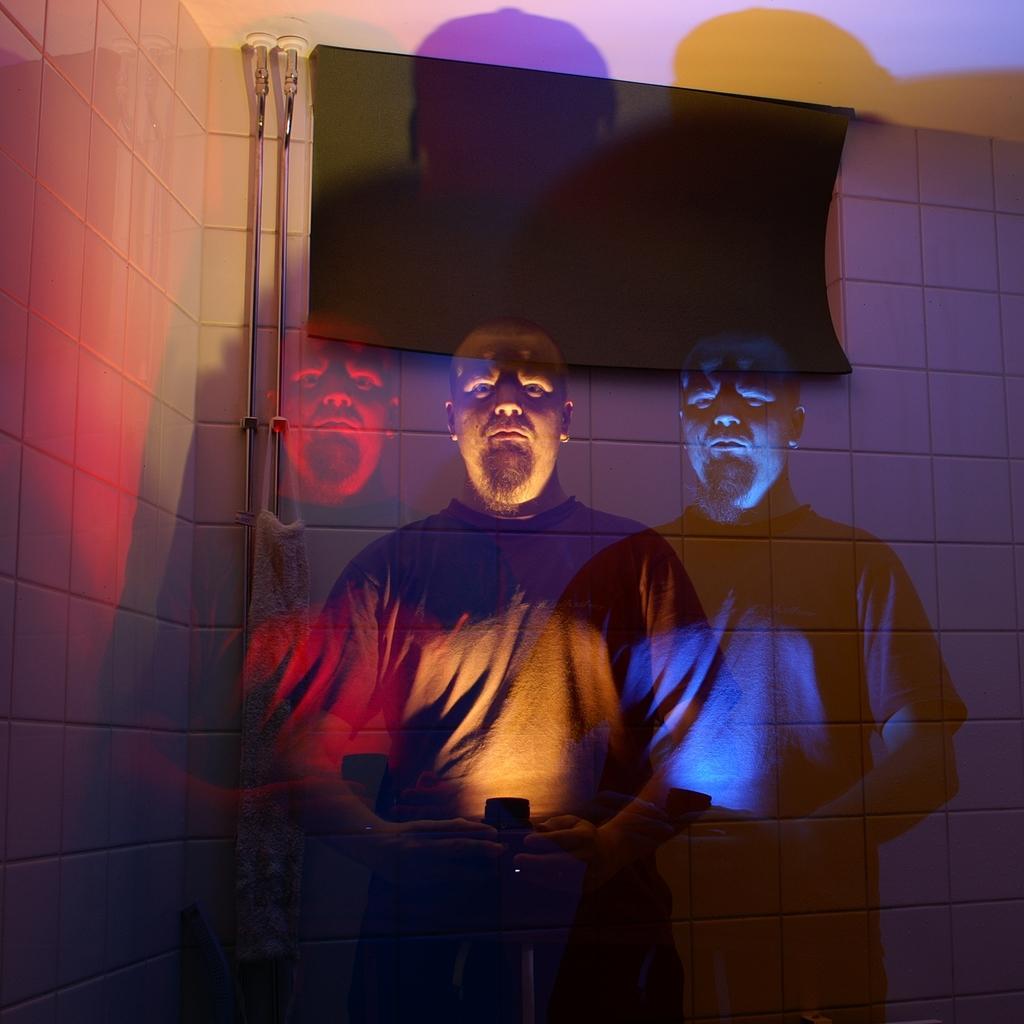In one or two sentences, can you explain what this image depicts? Here we can see a man. In the background there is a screen and wall. 